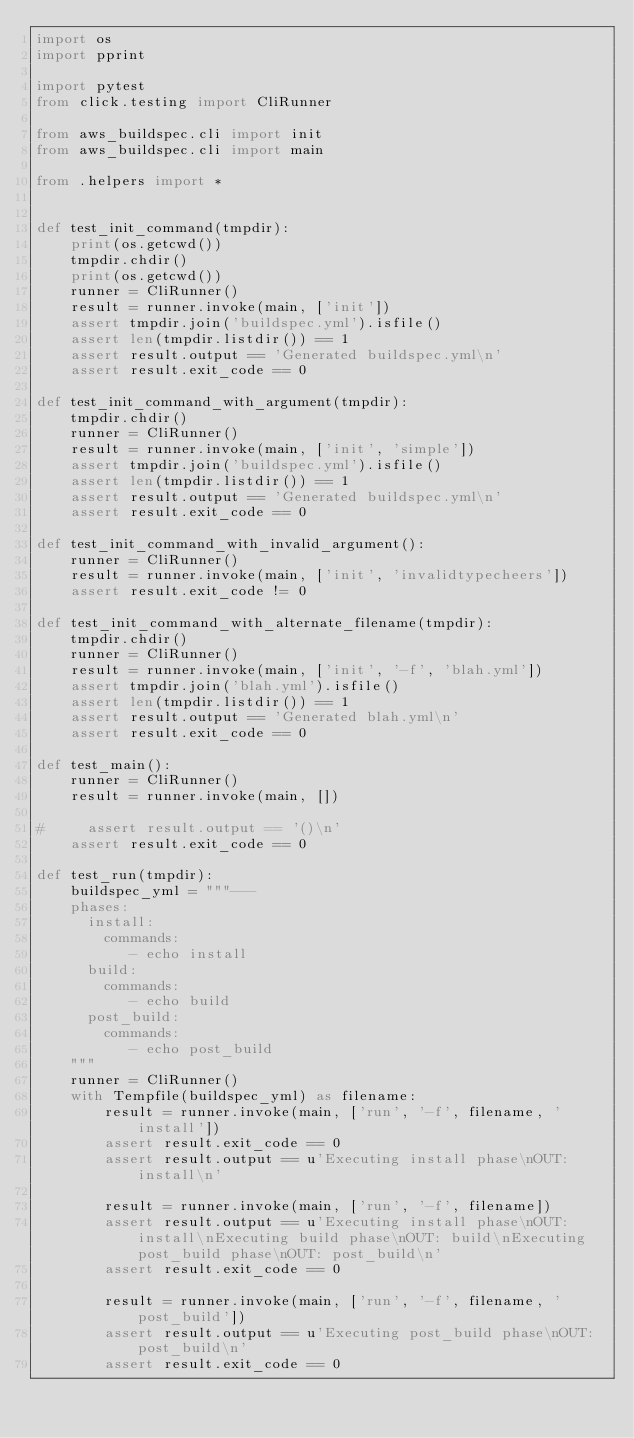<code> <loc_0><loc_0><loc_500><loc_500><_Python_>import os
import pprint

import pytest
from click.testing import CliRunner

from aws_buildspec.cli import init
from aws_buildspec.cli import main

from .helpers import *


def test_init_command(tmpdir):
    print(os.getcwd())
    tmpdir.chdir()
    print(os.getcwd())
    runner = CliRunner()
    result = runner.invoke(main, ['init'])
    assert tmpdir.join('buildspec.yml').isfile()
    assert len(tmpdir.listdir()) == 1
    assert result.output == 'Generated buildspec.yml\n'
    assert result.exit_code == 0

def test_init_command_with_argument(tmpdir):
    tmpdir.chdir()
    runner = CliRunner()
    result = runner.invoke(main, ['init', 'simple'])
    assert tmpdir.join('buildspec.yml').isfile()
    assert len(tmpdir.listdir()) == 1
    assert result.output == 'Generated buildspec.yml\n'
    assert result.exit_code == 0

def test_init_command_with_invalid_argument():
    runner = CliRunner()
    result = runner.invoke(main, ['init', 'invalidtypecheers'])
    assert result.exit_code != 0

def test_init_command_with_alternate_filename(tmpdir):
    tmpdir.chdir()
    runner = CliRunner()
    result = runner.invoke(main, ['init', '-f', 'blah.yml'])
    assert tmpdir.join('blah.yml').isfile()
    assert len(tmpdir.listdir()) == 1
    assert result.output == 'Generated blah.yml\n'
    assert result.exit_code == 0

def test_main():
    runner = CliRunner()
    result = runner.invoke(main, [])

#     assert result.output == '()\n'
    assert result.exit_code == 0

def test_run(tmpdir):
    buildspec_yml = """---
    phases:
      install:
        commands:
           - echo install
      build:
        commands:
           - echo build
      post_build:
        commands:
           - echo post_build
    """
    runner = CliRunner()
    with Tempfile(buildspec_yml) as filename:
        result = runner.invoke(main, ['run', '-f', filename, 'install'])
        assert result.exit_code == 0
        assert result.output == u'Executing install phase\nOUT: install\n'

        result = runner.invoke(main, ['run', '-f', filename])
        assert result.output == u'Executing install phase\nOUT: install\nExecuting build phase\nOUT: build\nExecuting post_build phase\nOUT: post_build\n'
        assert result.exit_code == 0

        result = runner.invoke(main, ['run', '-f', filename, 'post_build'])
        assert result.output == u'Executing post_build phase\nOUT: post_build\n'
        assert result.exit_code == 0
</code> 